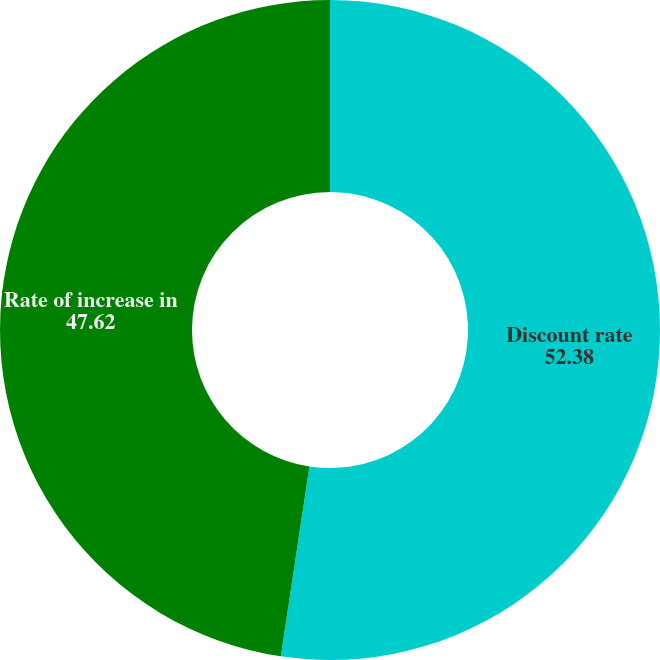Convert chart to OTSL. <chart><loc_0><loc_0><loc_500><loc_500><pie_chart><fcel>Discount rate<fcel>Rate of increase in<nl><fcel>52.38%<fcel>47.62%<nl></chart> 